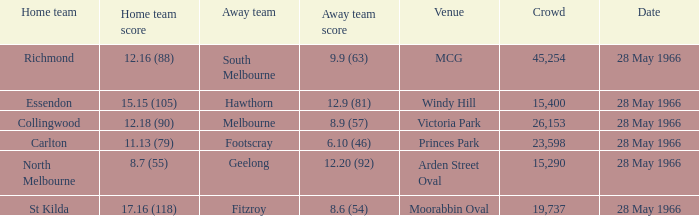Where is the home team for essendon located in terms of venue? Windy Hill. 